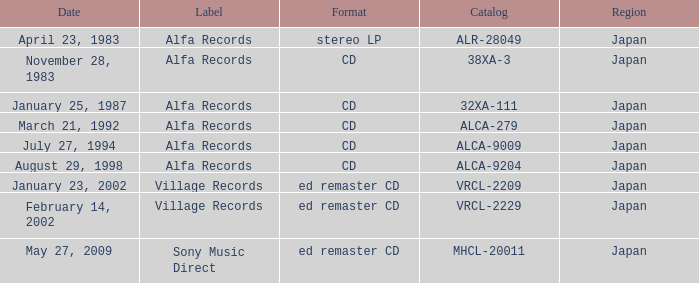Which label is dated February 14, 2002? Village Records. 